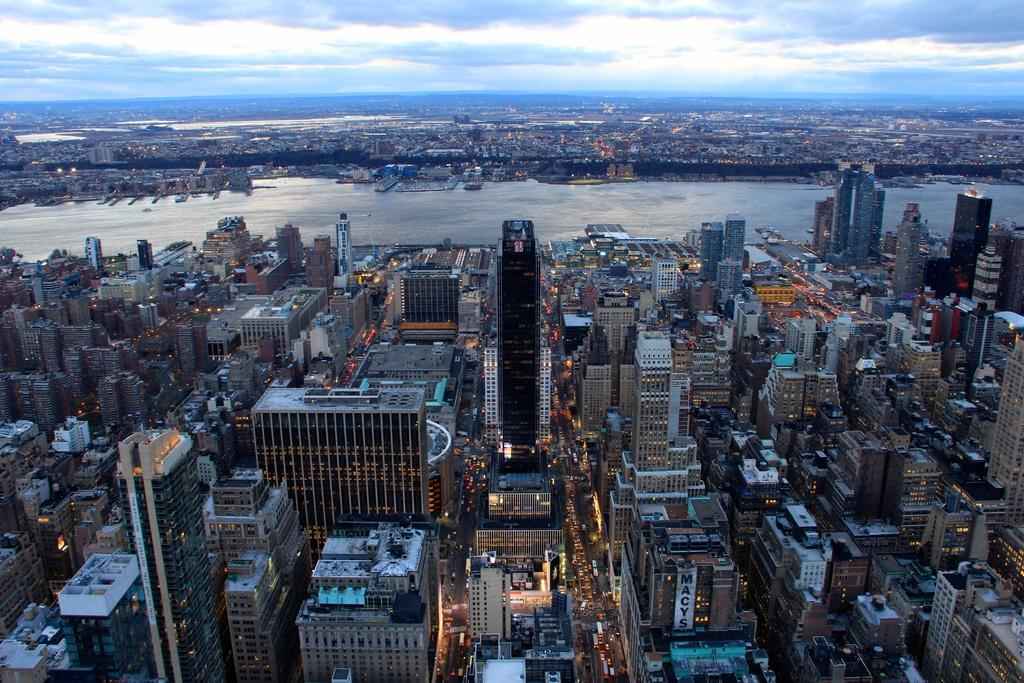What type of location is depicted in the image? The image shows a seaside city from a top view. What structures can be seen in the image? There are buildings in the image. What type of transportation infrastructure is visible? Roads are visible in the image. What is present on both sides of the sea? Vehicles are present on both sides of the sea. What is visible at the top of the image? The sky is visible at the top of the image. What type of mist can be seen covering the buildings in the image? There is no mist present in the image; the buildings are clearly visible. 